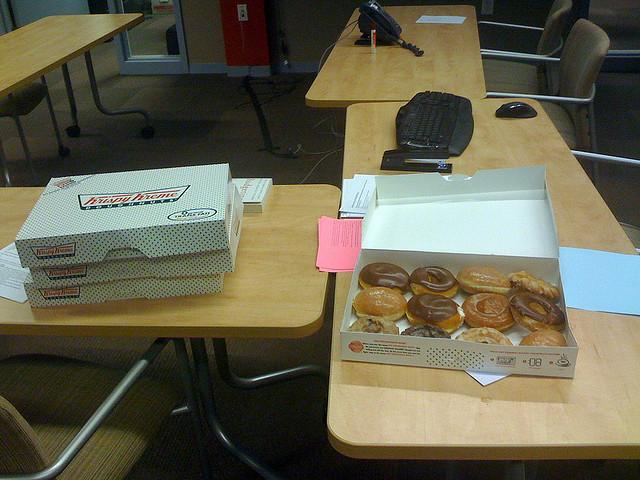Who is a competitor of this company? Please explain your reasoning. dunkin donuts. The competitor is dunkin. 